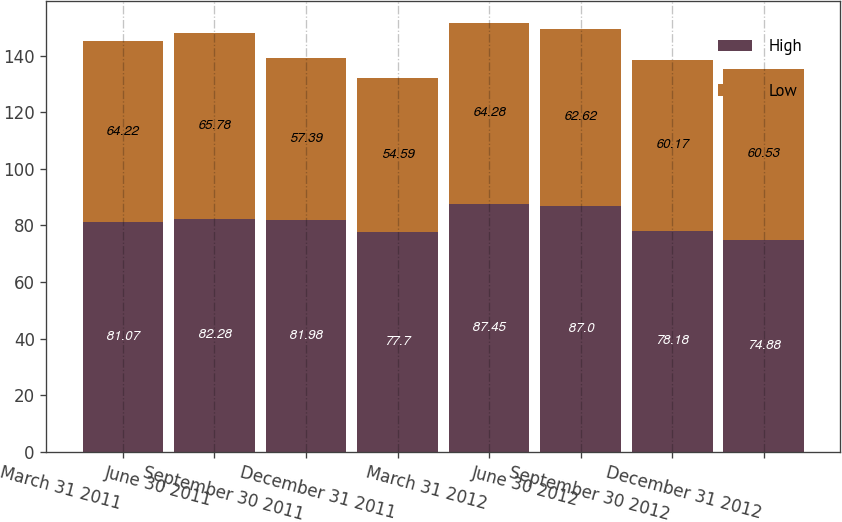Convert chart to OTSL. <chart><loc_0><loc_0><loc_500><loc_500><stacked_bar_chart><ecel><fcel>March 31 2011<fcel>June 30 2011<fcel>September 30 2011<fcel>December 31 2011<fcel>March 31 2012<fcel>June 30 2012<fcel>September 30 2012<fcel>December 31 2012<nl><fcel>High<fcel>81.07<fcel>82.28<fcel>81.98<fcel>77.7<fcel>87.45<fcel>87<fcel>78.18<fcel>74.88<nl><fcel>Low<fcel>64.22<fcel>65.78<fcel>57.39<fcel>54.59<fcel>64.28<fcel>62.62<fcel>60.17<fcel>60.53<nl></chart> 